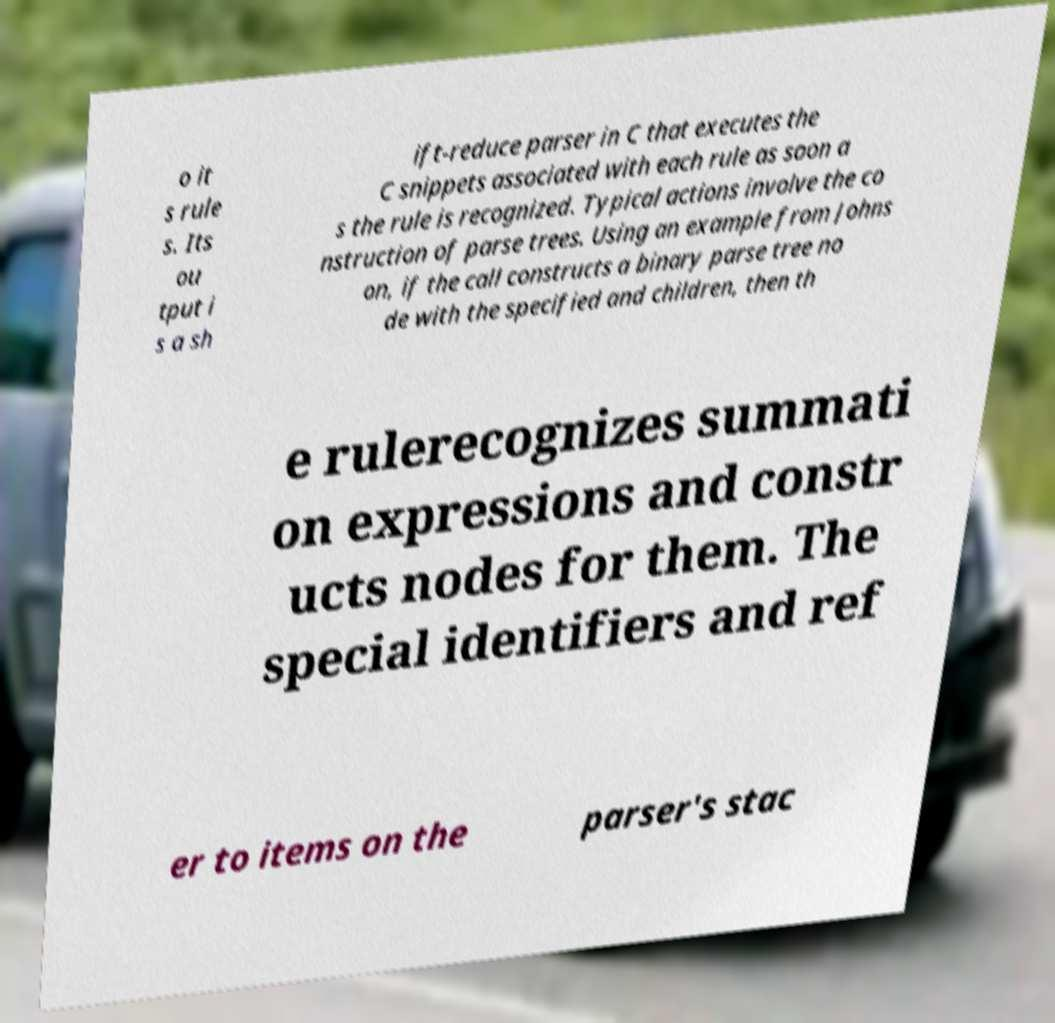Please identify and transcribe the text found in this image. o it s rule s. Its ou tput i s a sh ift-reduce parser in C that executes the C snippets associated with each rule as soon a s the rule is recognized. Typical actions involve the co nstruction of parse trees. Using an example from Johns on, if the call constructs a binary parse tree no de with the specified and children, then th e rulerecognizes summati on expressions and constr ucts nodes for them. The special identifiers and ref er to items on the parser's stac 